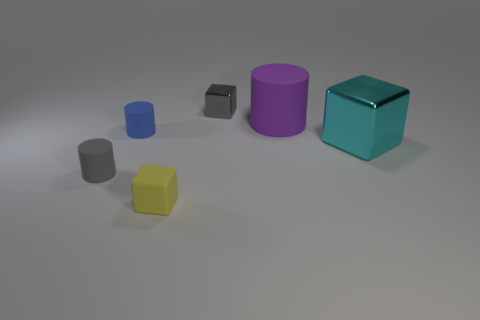Subtract all tiny gray blocks. How many blocks are left? 2 Add 3 large brown matte balls. How many objects exist? 9 Subtract all yellow cubes. How many cubes are left? 2 Subtract 2 cubes. How many cubes are left? 1 Subtract all cubes. Subtract all tiny rubber objects. How many objects are left? 0 Add 5 matte cylinders. How many matte cylinders are left? 8 Add 5 gray metallic objects. How many gray metallic objects exist? 6 Subtract 0 brown blocks. How many objects are left? 6 Subtract all yellow cylinders. Subtract all cyan spheres. How many cylinders are left? 3 